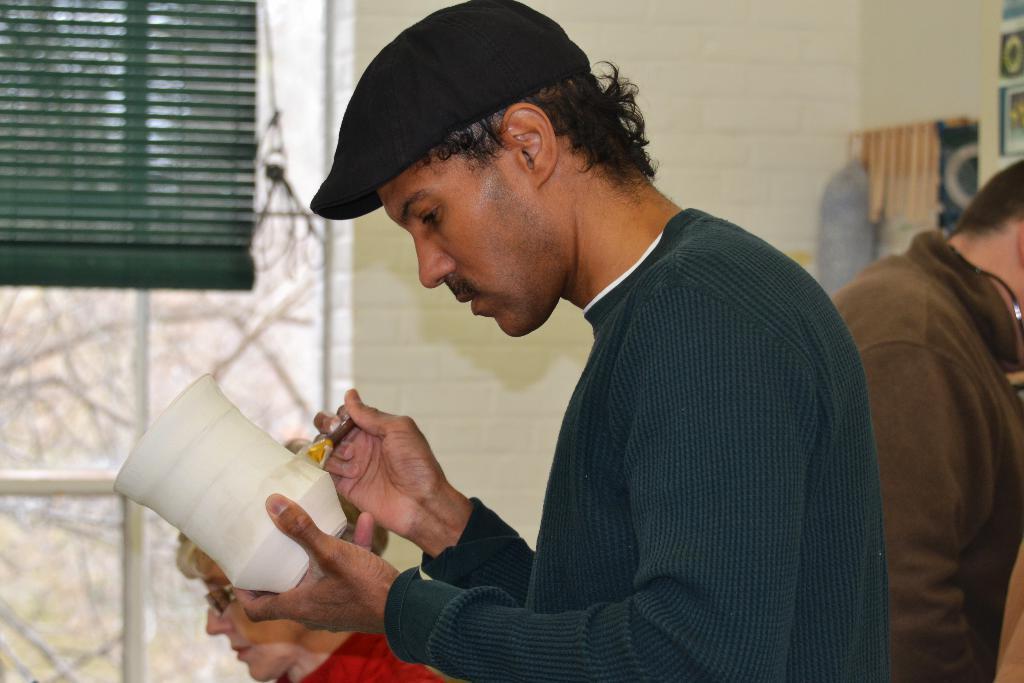How would you summarize this image in a sentence or two? There is a person wearing cap is holding a brush and a pot. In the back there are other people. Also there is a window with curtain. And there is a wall in the background. 